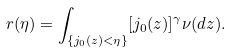<formula> <loc_0><loc_0><loc_500><loc_500>r ( \eta ) = \int _ { \{ j _ { 0 } ( z ) < \eta \} } [ j _ { 0 } ( z ) ] ^ { \gamma } \nu ( d z ) .</formula> 